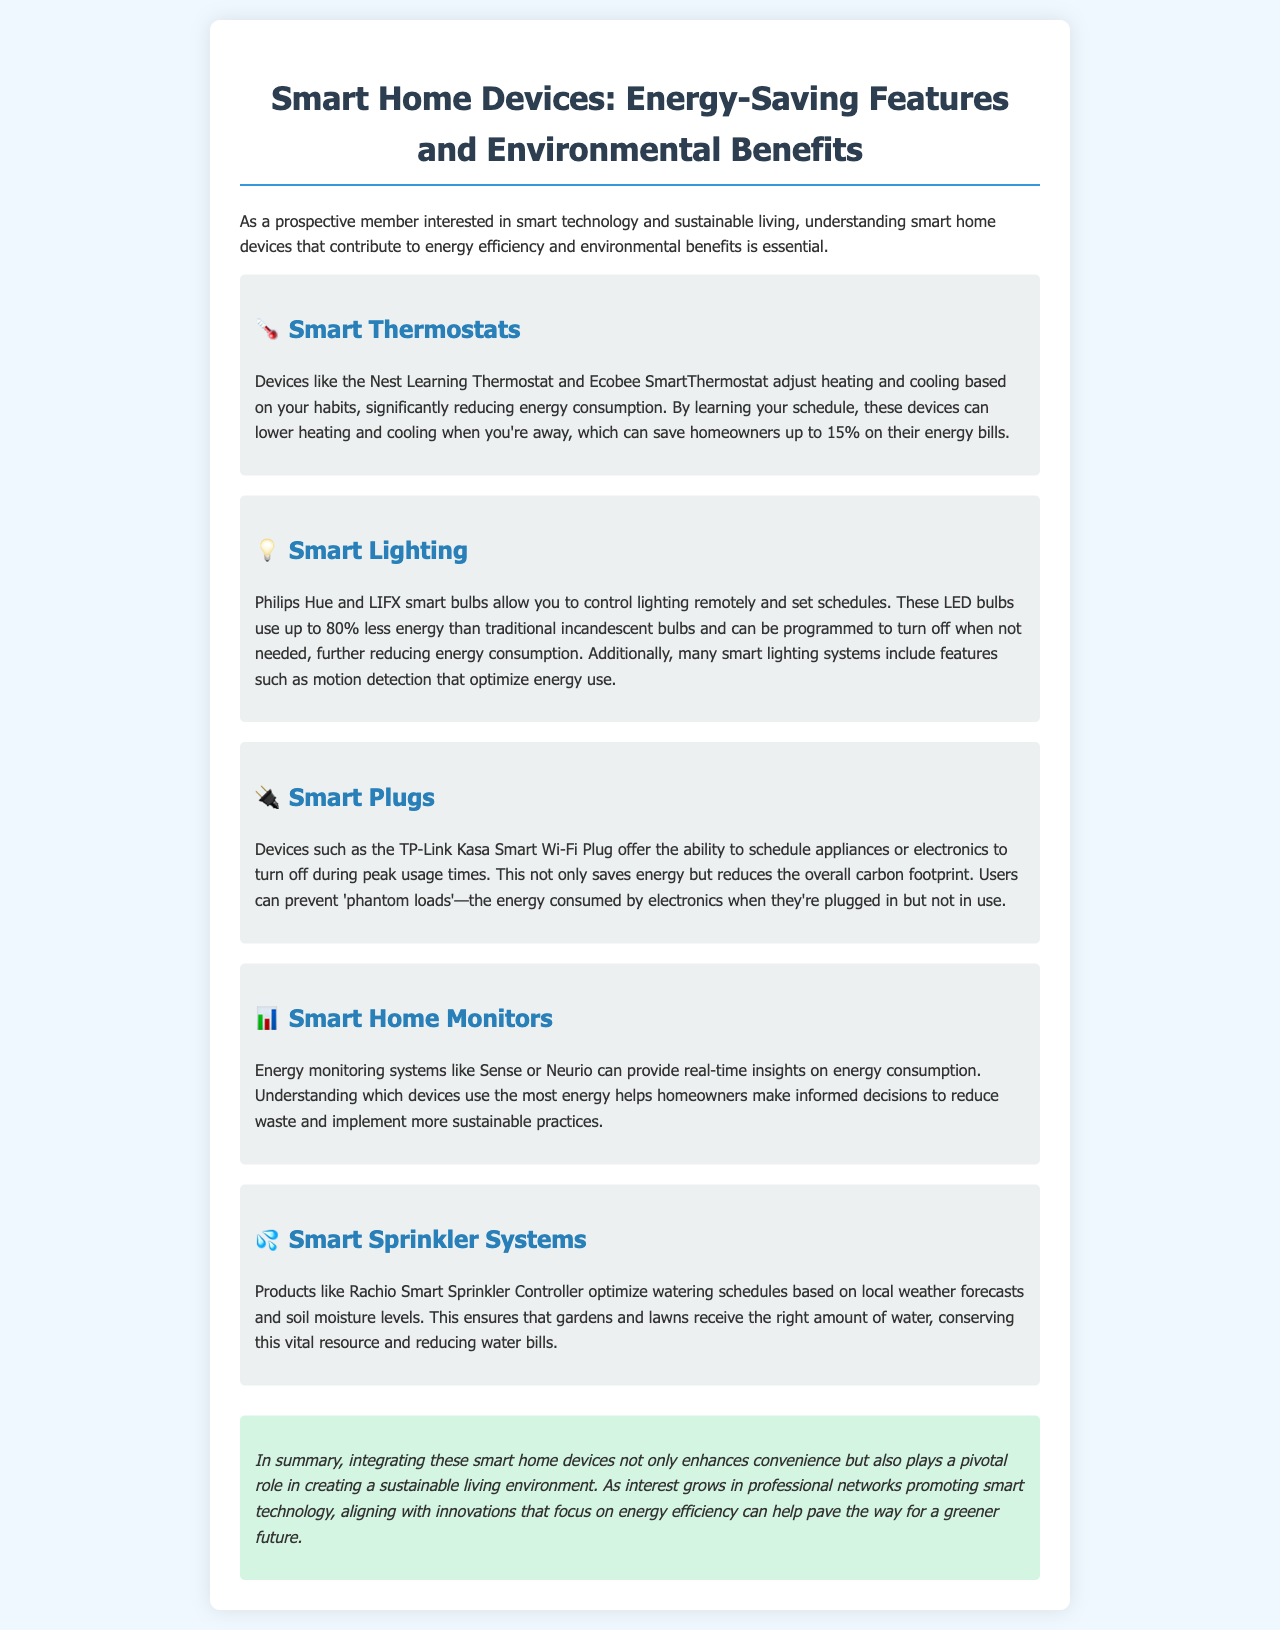What do smart thermostats help reduce? Smart thermostats help reduce energy consumption.
Answer: energy consumption How much can homeowners save on energy bills with smart thermostats? Homeowners can save up to 15% on their energy bills.
Answer: 15% What percentage less energy do smart lighting systems use compared to traditional bulbs? Smart lighting systems use up to 80% less energy than traditional incandescent bulbs.
Answer: 80% What type of loads can smart plugs help prevent? Smart plugs can help prevent 'phantom loads.'
Answer: phantom loads What do energy monitoring systems provide insights on? Energy monitoring systems provide insights on energy consumption.
Answer: energy consumption Which smart device optimizes watering schedules based on weather forecasts? Rachio Smart Sprinkler Controller optimizes watering schedules.
Answer: Rachio Smart Sprinkler Controller What is the main focus of the document? The main focus of the document is smart home devices that contribute to energy efficiency and environmental benefits.
Answer: energy efficiency and environmental benefits What is the purpose of the conclusion in the document? The conclusion emphasizes the importance of integrating smart devices for sustainability.
Answer: sustainability Which systems include motion detection features? Smart lighting systems often include motion detection features.
Answer: Smart lighting systems 